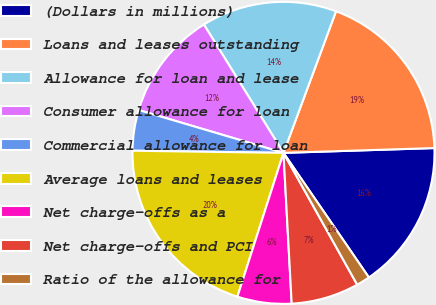Convert chart. <chart><loc_0><loc_0><loc_500><loc_500><pie_chart><fcel>(Dollars in millions)<fcel>Loans and leases outstanding<fcel>Allowance for loan and lease<fcel>Consumer allowance for loan<fcel>Commercial allowance for loan<fcel>Average loans and leases<fcel>Net charge-offs as a<fcel>Net charge-offs and PCI<fcel>Ratio of the allowance for<nl><fcel>15.94%<fcel>18.84%<fcel>14.49%<fcel>11.59%<fcel>4.35%<fcel>20.29%<fcel>5.8%<fcel>7.25%<fcel>1.45%<nl></chart> 